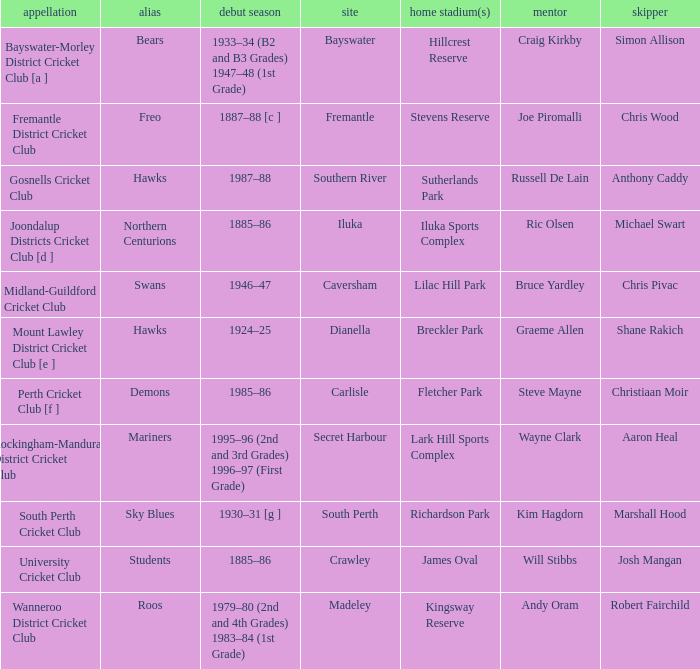What is the location for the club with the nickname the bears? Bayswater. 